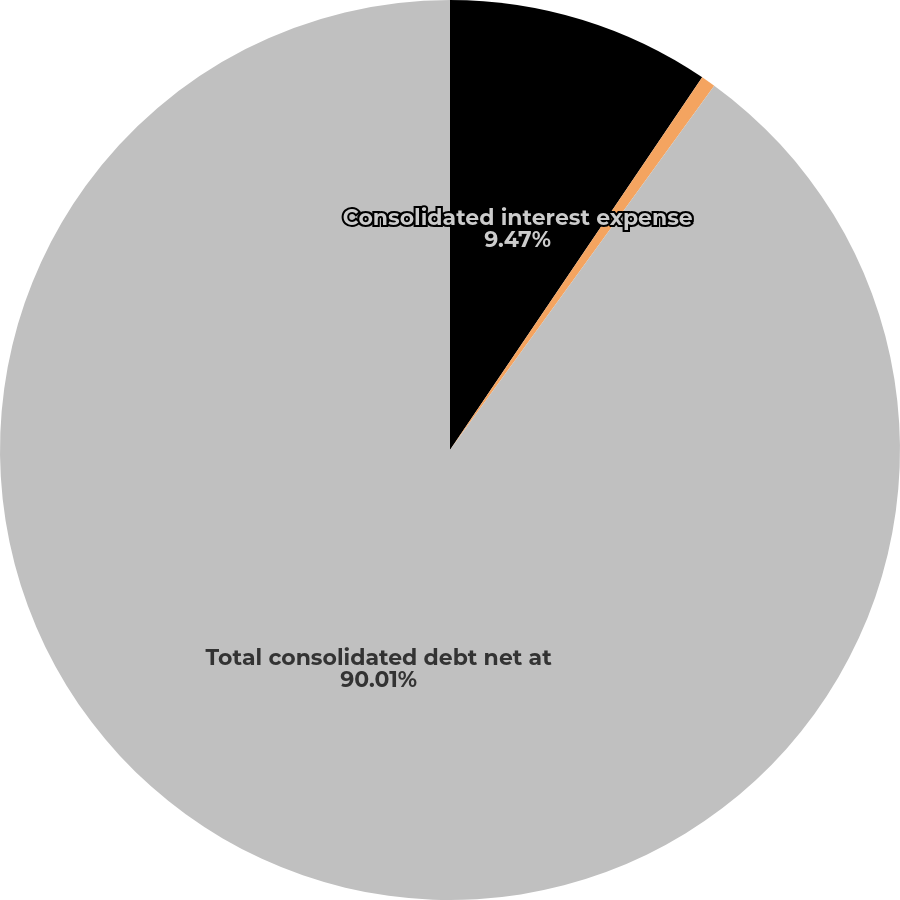<chart> <loc_0><loc_0><loc_500><loc_500><pie_chart><fcel>Consolidated interest expense<fcel>Consolidated other income<fcel>Total consolidated debt net at<nl><fcel>9.47%<fcel>0.52%<fcel>90.02%<nl></chart> 